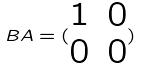<formula> <loc_0><loc_0><loc_500><loc_500>B A = ( \begin{matrix} 1 & 0 \\ 0 & 0 \end{matrix} )</formula> 